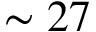Convert formula to latex. <formula><loc_0><loc_0><loc_500><loc_500>\sim 2 7</formula> 